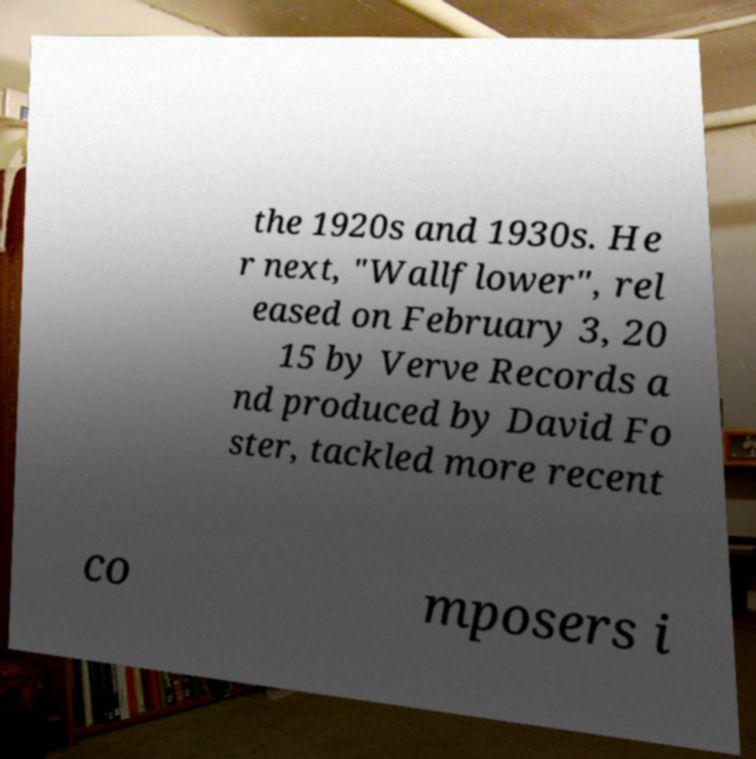I need the written content from this picture converted into text. Can you do that? the 1920s and 1930s. He r next, "Wallflower", rel eased on February 3, 20 15 by Verve Records a nd produced by David Fo ster, tackled more recent co mposers i 